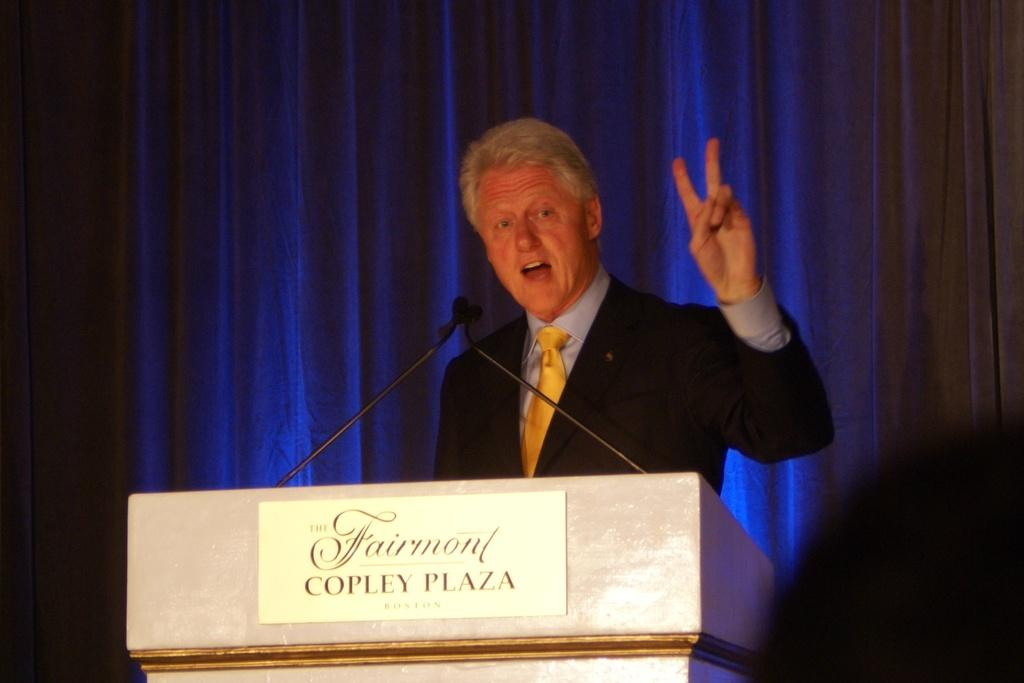<image>
Present a compact description of the photo's key features. A man making a speech at a podium labelled Fairmont Copley Plaza 